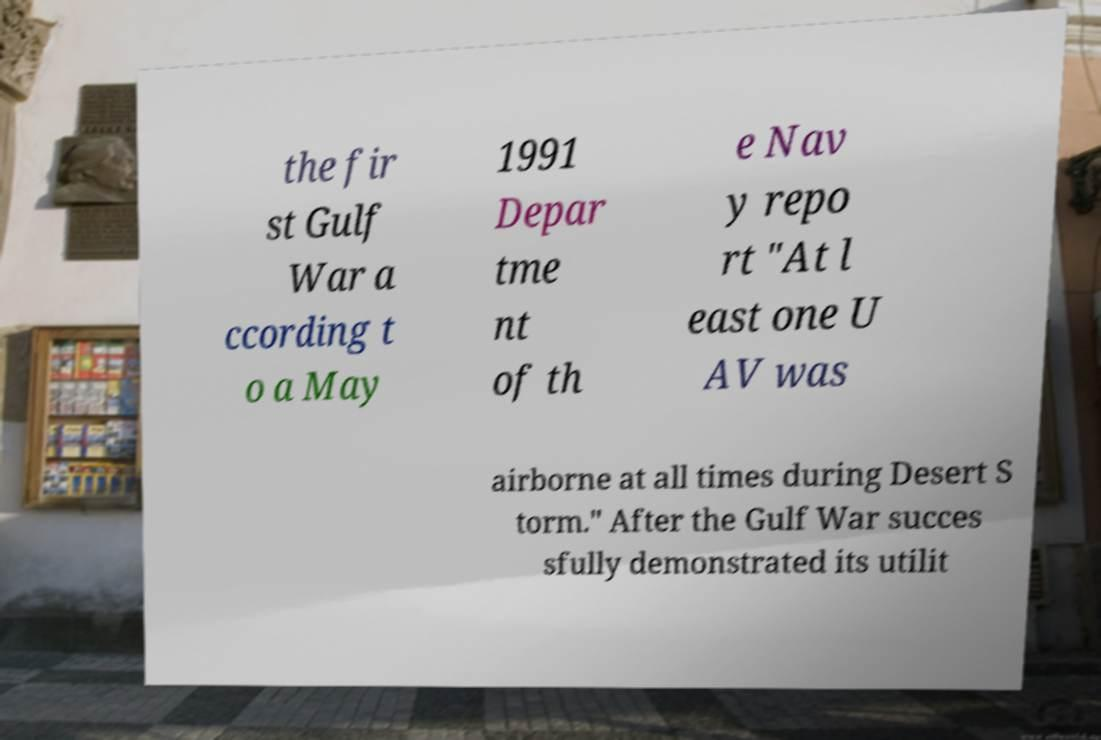Could you extract and type out the text from this image? the fir st Gulf War a ccording t o a May 1991 Depar tme nt of th e Nav y repo rt "At l east one U AV was airborne at all times during Desert S torm." After the Gulf War succes sfully demonstrated its utilit 